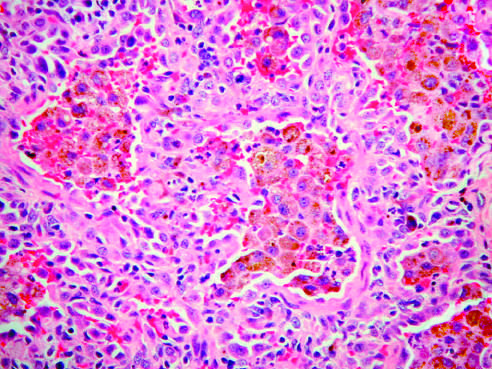does cross-section of aortic media from a patient with marfan syndrome demonstrate large numbers of intraalveolar hemosiderin-laden macrophages on a background of thickened fibrous septa?
Answer the question using a single word or phrase. No 